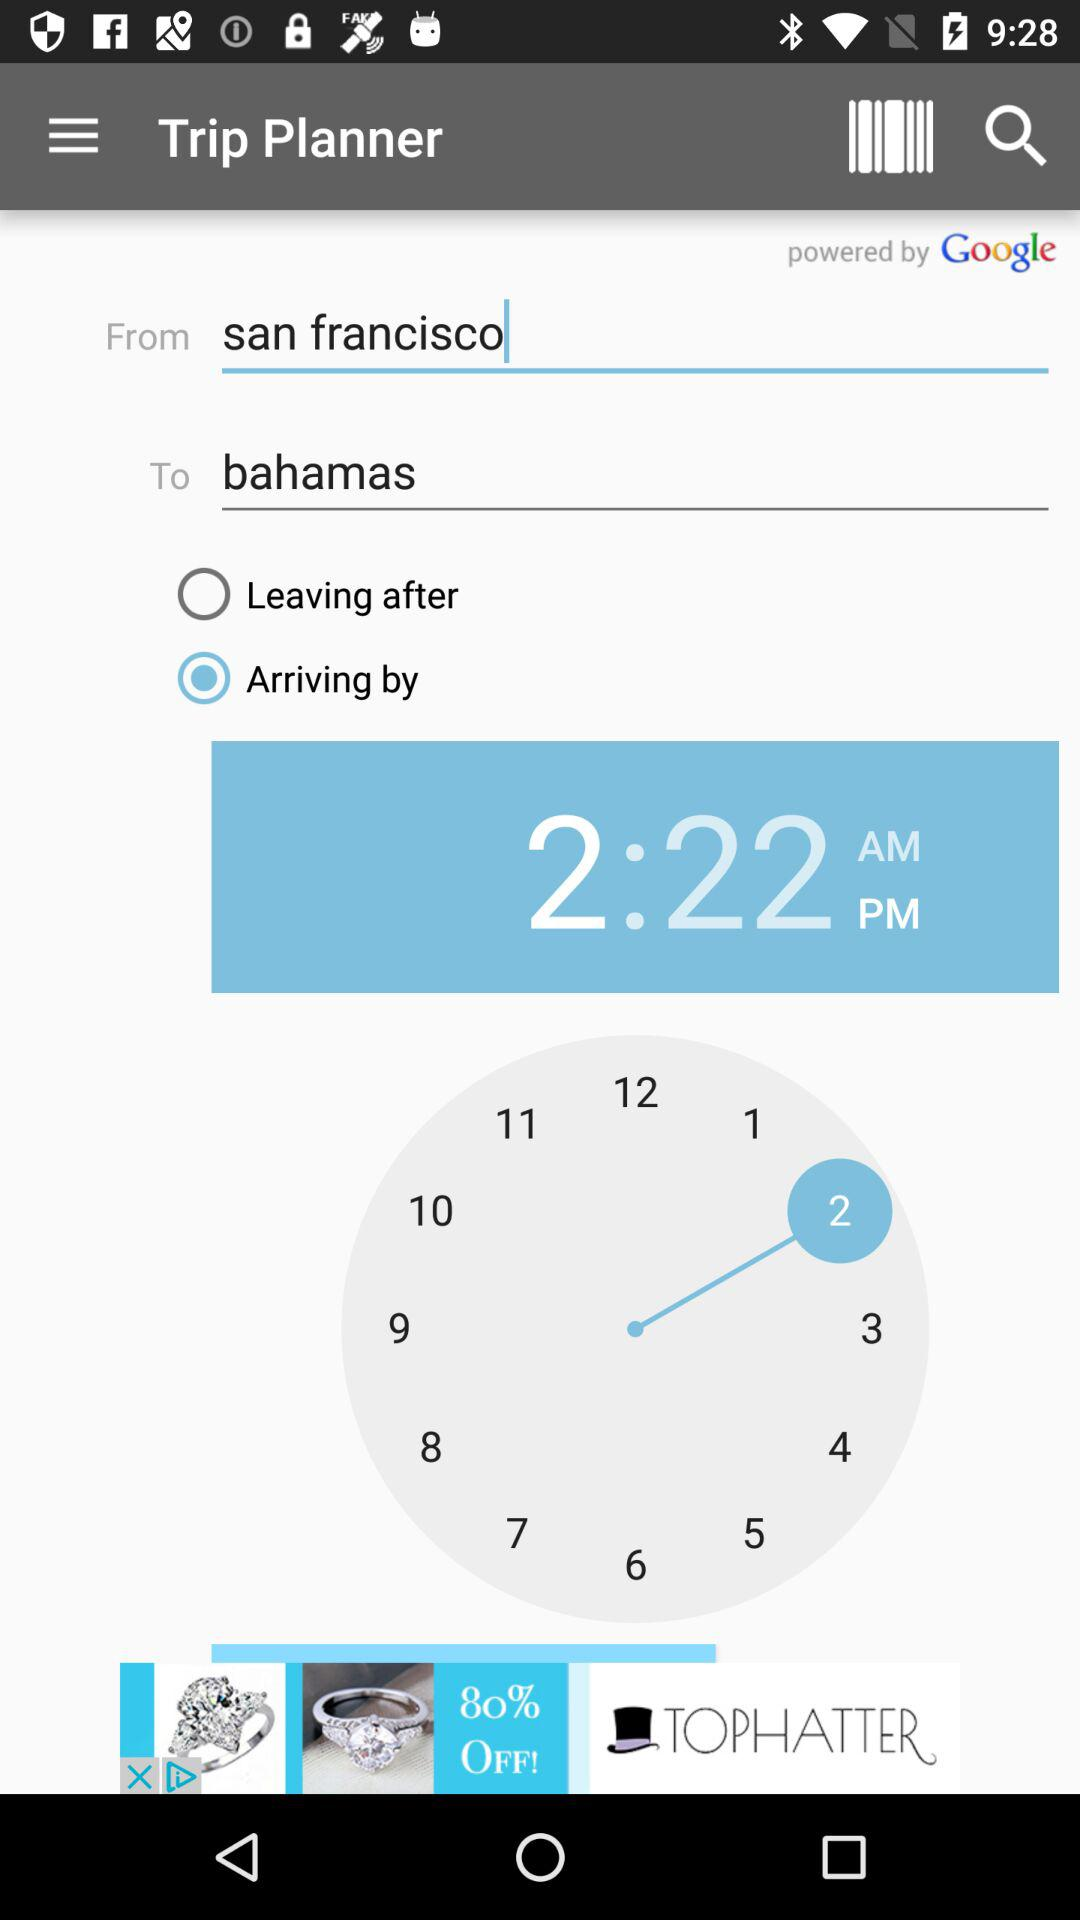What is the departure location? The departure location is San Francisco. 